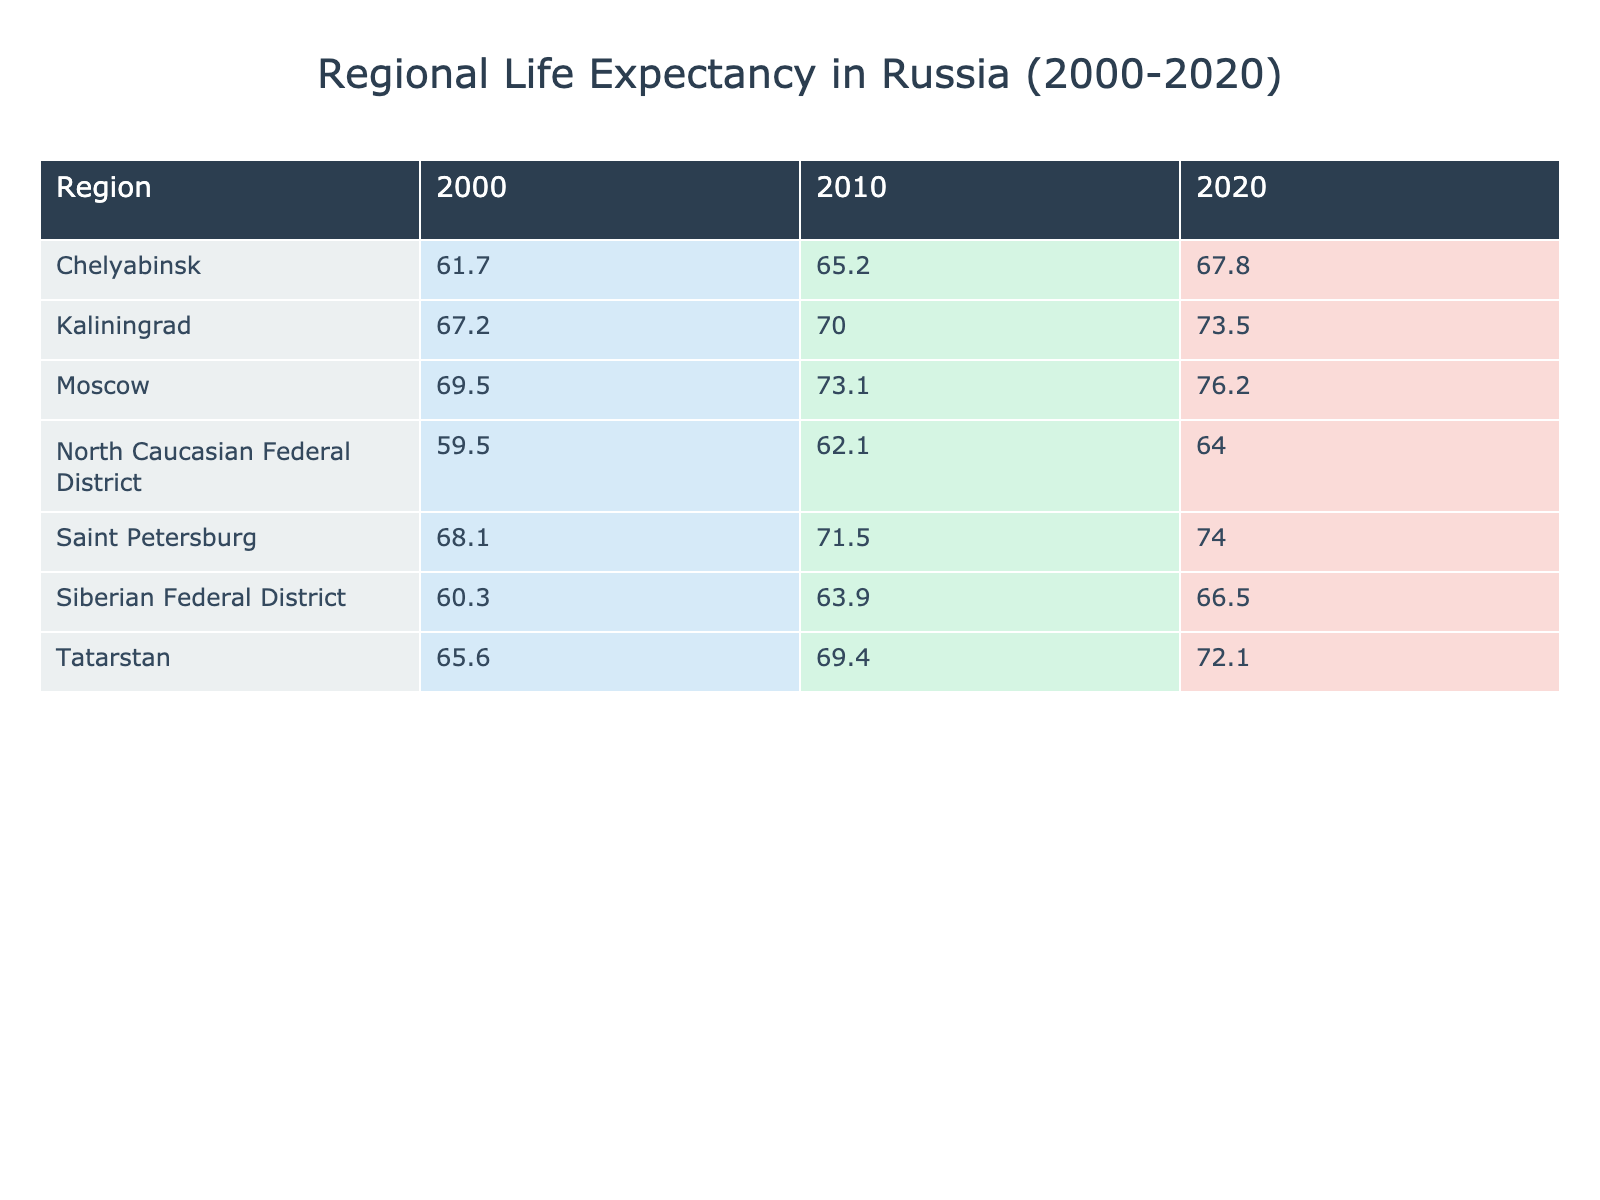What was the life expectancy in Moscow in 2000? Referring to the table, the value listed for Moscow under the year 2000 is 69.5 years.
Answer: 69.5 What was the increase in life expectancy in Saint Petersburg from 2010 to 2020? The life expectancy in Saint Petersburg in 2010 was 71.5 years, and in 2020 it was 74.0 years. The increase is calculated as 74.0 - 71.5 = 2.5 years.
Answer: 2.5 Is the life expectancy in Siberian Federal District higher than in North Caucasian Federal District in 2010? From the table, the life expectancy in Siberian Federal District for 2010 is 63.9 years, while for North Caucasian Federal District it is 62.1 years. Since 63.9 is greater than 62.1, the answer is yes.
Answer: Yes What region had the highest life expectancy in 2020? In reviewing the table under the year 2020, Moscow has the highest life expectancy at 76.2 years, compared to others: Saint Petersburg at 74.0 years, Tatarstan at 72.1 years, and others listed fall below that.
Answer: Moscow What was the average life expectancy across all regions in 2010? To calculate the average for 2010: the life expectancies are 73.1 (Moscow), 71.5 (Saint Petersburg), 65.2 (Chelyabinsk), 69.4 (Tatarstan), 63.9 (Siberian Federal District), and 62.1 (North Caucasian Federal District). Their sum is 73.1 + 71.5 + 65.2 + 69.4 + 63.9 + 62.1 = 405.2. There are 6 regions, so the average is 405.2 / 6 ≈ 67.53 years.
Answer: 67.53 In which year did Tatarstan have a life expectancy lower than Chelyabinsk? Looking at the table, Tatarstan had a life expectancy lower than Chelyabinsk only in the year 2000 (Tatarstan 65.6 vs. Chelyabinsk 61.7), while in 2010 and 2020, Tatarstan had higher life expectancies.
Answer: 2000 How much did Chelyabinsk's life expectancy improve from 2000 to 2020? The life expectancy for Chelyabinsk in 2000 was 61.7 years, and in 2020 it was 67.8 years. To find the improvement, subtract the earlier year from the later year: 67.8 - 61.7 = 6.1 years increase.
Answer: 6.1 Was the life expectancy in Kaliningrad in 2010 above 70 years? Checking the values in the table, Kaliningrad's life expectancy in 2010 was 70.0 years. Since 70.0 is equal to 70, the answer is yes.
Answer: Yes Which region showed the smallest improvement in life expectancy from 2000 to 2020? Comparing the improvements: Moscow (6.7), Saint Petersburg (5.9), Chelyabinsk (6.1), Tatarstan (6.5), Siberian Federal District (6.2), North Caucasian Federal District (4.5) and Kaliningrad (6.3). The smallest improvement is in North Caucasian Federal District with 4.5 years.
Answer: North Caucasian Federal District 